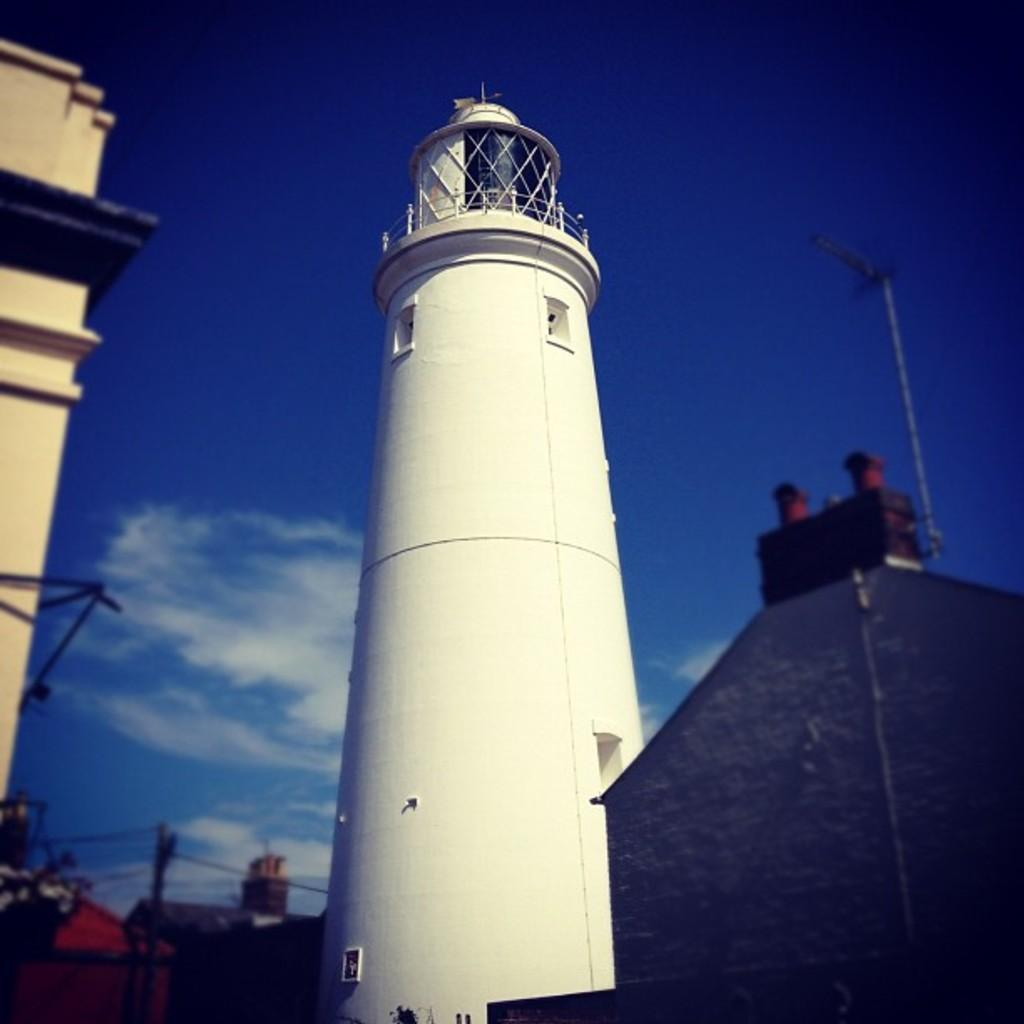What is the main structure in the image? There is a tower in the image. What other structures can be seen in the image? There are buildings in the image. What is the pole used for in the image? The purpose of the pole is not specified in the image. What is the color of the sky in the image? The sky is blue in the image. What can be seen in the sky besides the blue color? There are clouds in the image. What might be used for safety or support in the town depicted in the image? There is a railing in the town depicted in the image. What type of prose is being recited by the clouds in the image? There is no indication in the image that the clouds are reciting any prose. What happens when the milk is poured into the tower in the image? There is no milk present in the image, so this action cannot occur. 